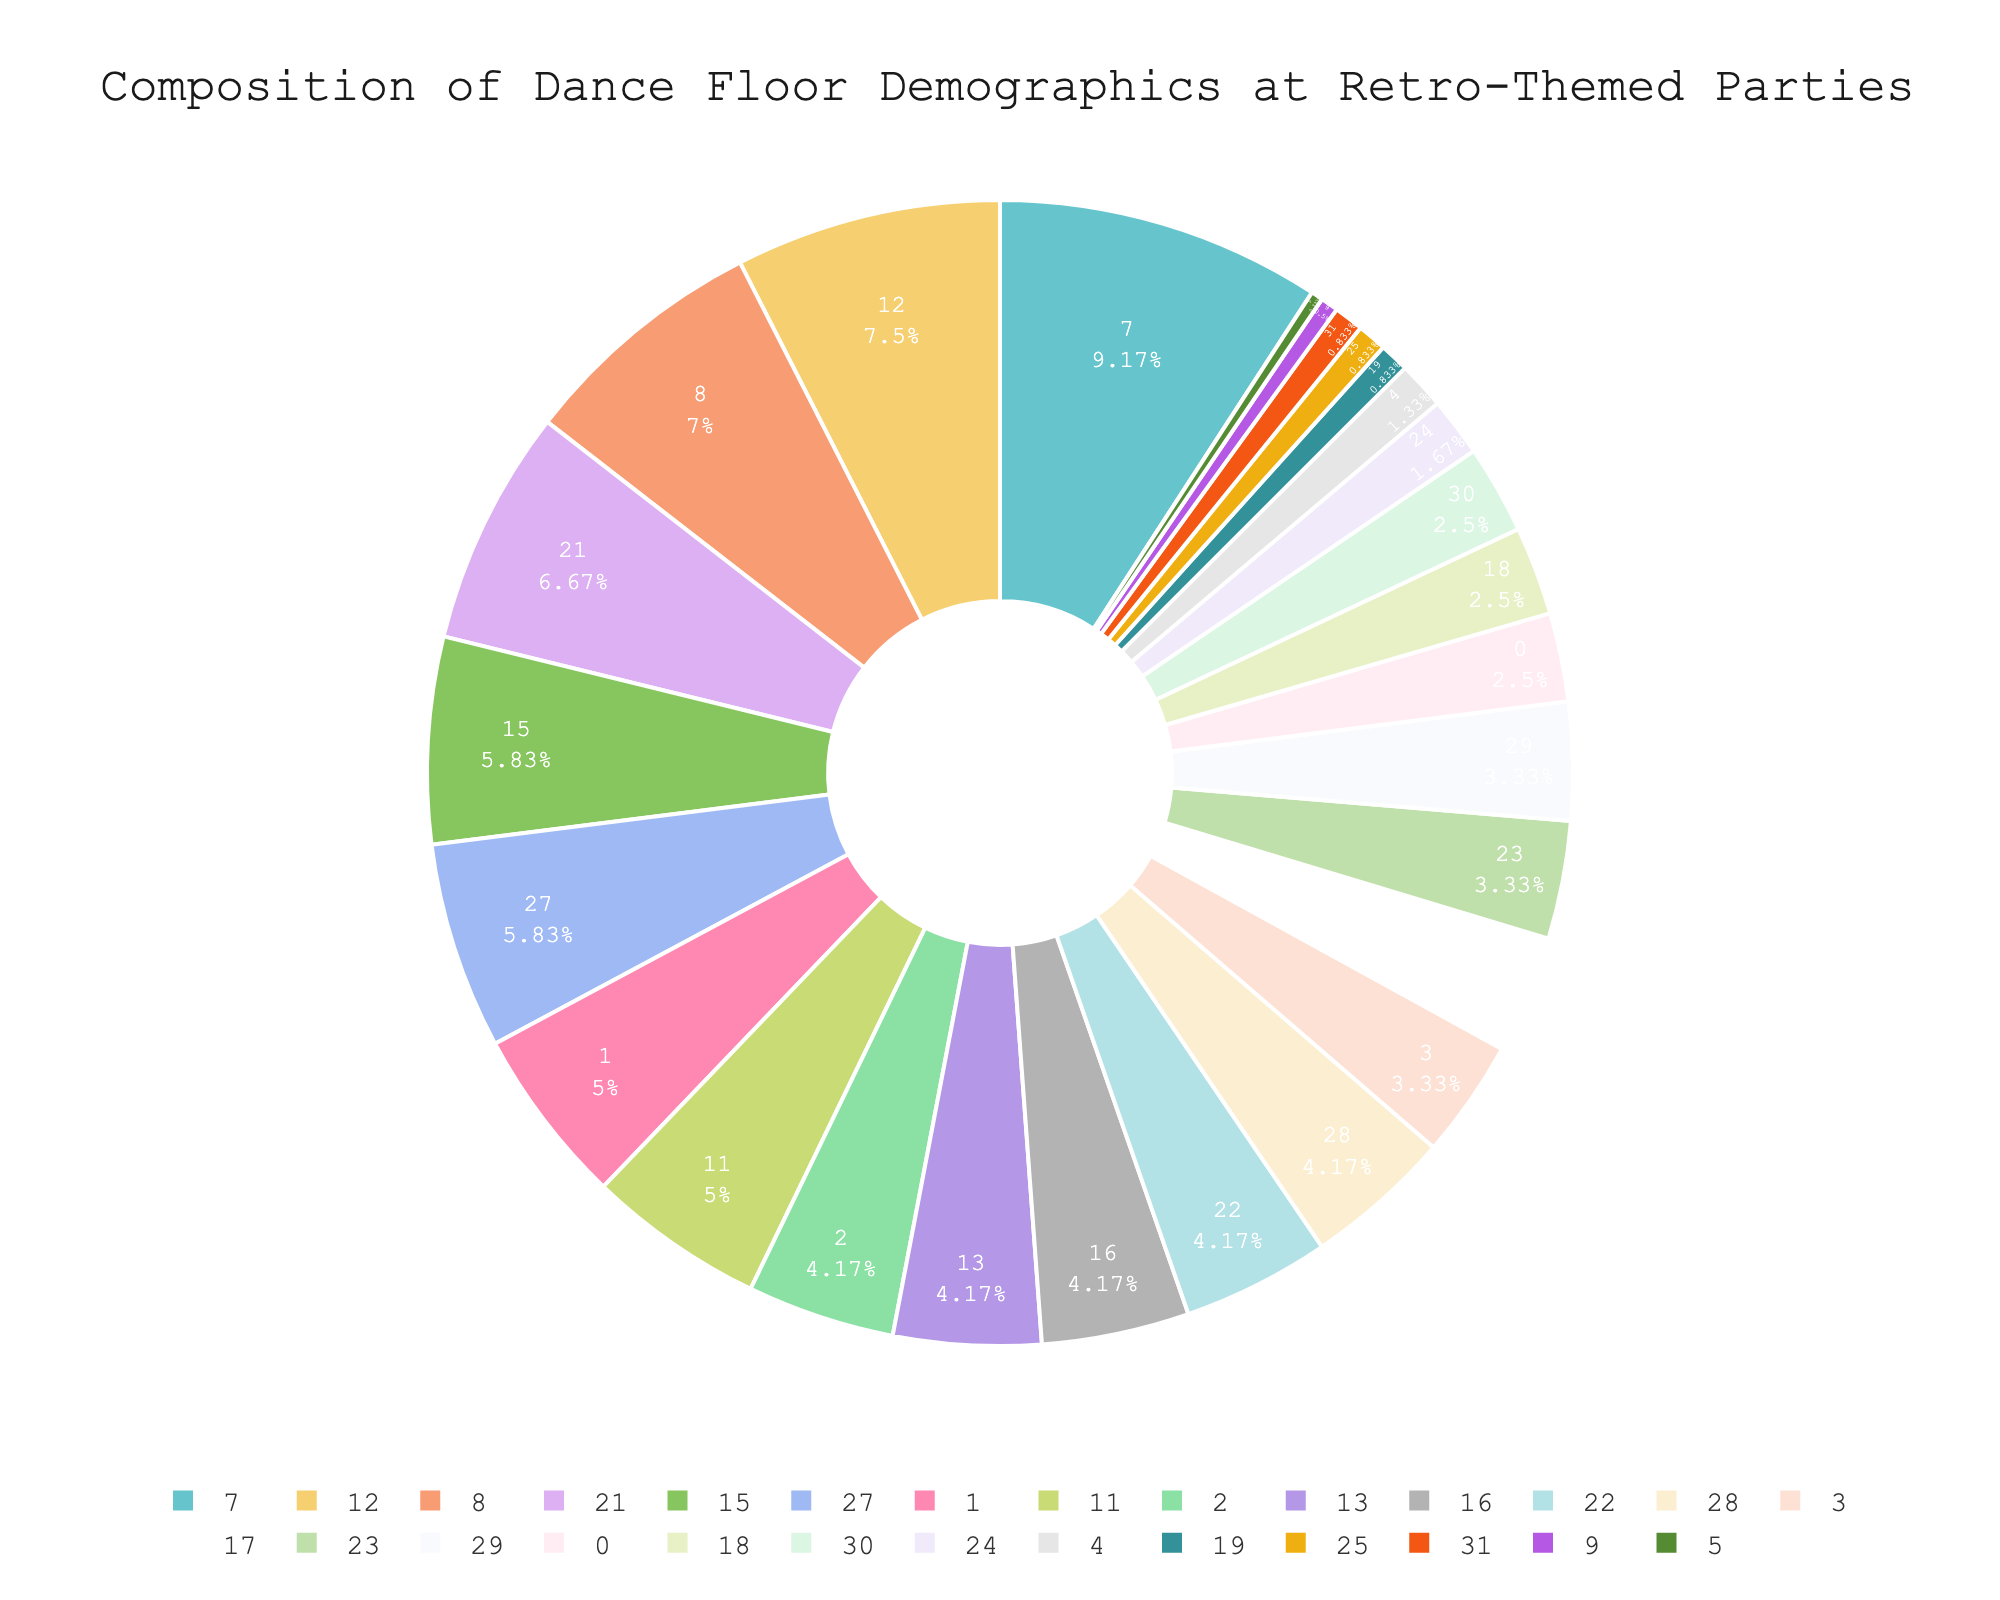Which age group has the highest percentage on the dance floor? Looking at the pie chart, the age group with the highest percentage is identified by its segment size. The largest segment corresponds to the 26-35 age group.
Answer: 26-35 What is the combined percentage of people aged 46-65 on the dance floor? Sum the percentages of the 46-55 group and the 56-65 group. That’s 20% + 8% = 28%.
Answer: 28% Is the percentage of females on the dance floor greater than that of males? Compare the segments representing females and males. The female segment is labeled with 55%, and the male segment is 42%, making females have a greater percentage.
Answer: Yes Which gender has the smallest representation on the dance floor? Find the smallest percentage in the gender category. Non-binary has the smallest percentage at 3%.
Answer: Non-binary What is the percentage difference between beginners and advanced dancers? Subtract the percentage of advanced dancers from beginners. That’s 30% - 25% = 5%.
Answer: 5% Who is the most favorite disco artist according to the pie chart? Identify the largest segment in the "Favorite Disco Artists" section. Sylvester has the highest percentage at 35%.
Answer: Sylvester Which outfit style is more common: Bell-bottoms or Platform Shoes? Compare the segments for Bell-bottoms and Platform Shoes. Bell-bottoms are at 25%, whereas Platform Shoes are at 20%.
Answer: Bell-bottoms What fraction of the dance floor population prefers non-alcoholic drinks? Identify the segment for non-alcoholic drinks, which is 15%. Take this percentage as 15 out of 100, simplifying it to the fraction 3/20.
Answer: 3/20 How many of the dancers prefer Sylvester over Chic? Find the percentages of both, which are 35% for Sylvester and 5% for Chic. The difference is 35% - 5% = 30%.
Answer: 30% What percentage of dancers aged 18-25 combined with those aged 36-45? Add the percentages of the 18-25 group and the 36-45 group. That’s 15% + 25% = 40%.
Answer: 40% 